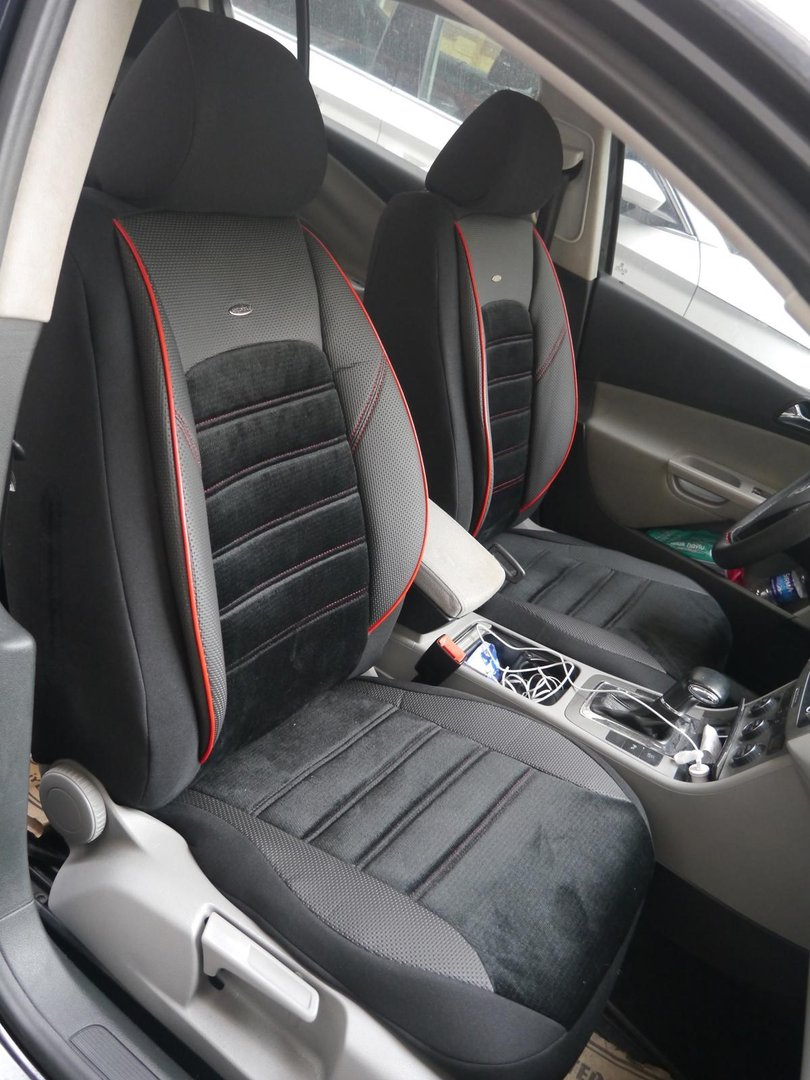What items can be identified on the passenger seat, and what do they suggest about the habits or preferences of the car owner? Upon examining the passenger seat, a white charging cable and an object with a blue cap can be identified. The object appears to be either a water bottle or a cleaning product. The presence of these items suggests several things about the car owner's habits and preferences. The charging cable hints that the owner values staying connected and ensuring their devices are always powered, indicating a reliance on technology or frequent travel requiring charged devices. The blue-capped object suggests that the owner values either hydration, if it's a water bottle, or cleanliness, if it's a cleaning product. This implies that the owner either aims to stay hydrated and healthy while on the move or maintains a clean and orderly car environment. Collectively, these items reveal that convenience, technological readiness, and either health or cleanliness are important to the owner. 